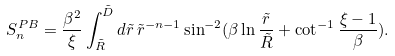<formula> <loc_0><loc_0><loc_500><loc_500>S _ { n } ^ { P B } = \frac { \beta ^ { 2 } } { \xi } \int _ { \tilde { R } } ^ { \tilde { D } } { d } { \tilde { r } } \, { \tilde { r } } ^ { - n - 1 } \sin ^ { - 2 } ( \beta \ln \frac { \tilde { r } } { \tilde { R } } + \cot ^ { - 1 } \frac { \xi - 1 } { \beta } ) .</formula> 